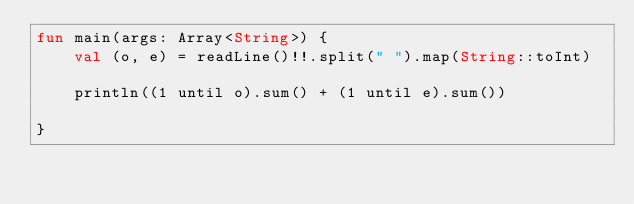<code> <loc_0><loc_0><loc_500><loc_500><_Kotlin_>fun main(args: Array<String>) {
    val (o, e) = readLine()!!.split(" ").map(String::toInt)

    println((1 until o).sum() + (1 until e).sum())

}



</code> 